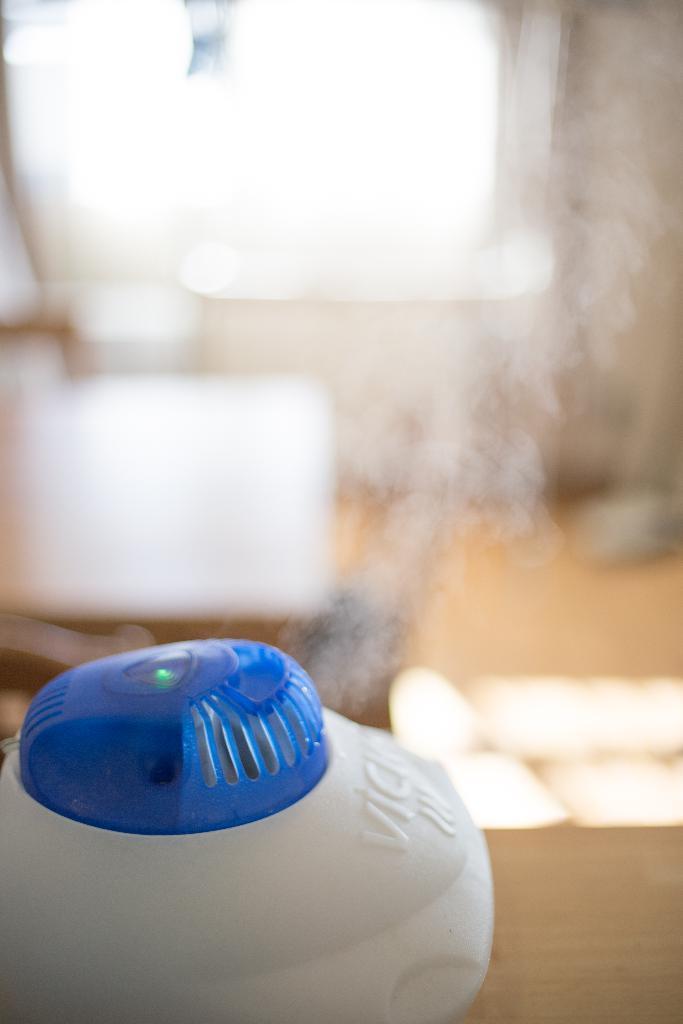How would you summarize this image in a sentence or two? At the bottom of the image we can see a table. On the table we can see a mosquito killer. In the background of the image we can see the smoke, lamp, floor, wall and window. 